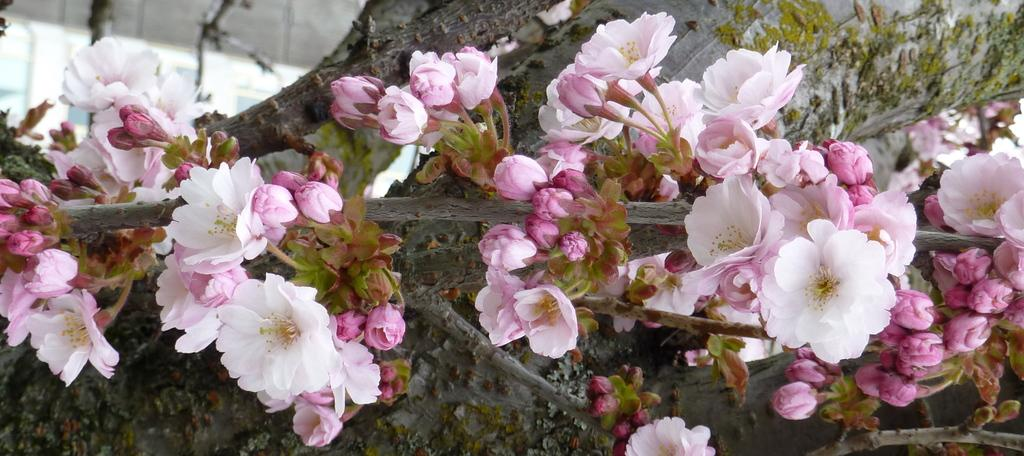What type of plants can be seen in the image? There are flowers in the image. Can you describe the stage of growth for some of the plants in the image? Yes, there are buds in the image, which are flowers in the early stages of development. What type of afterthought can be seen in the image? There is no afterthought present in the image. Can you tell me how many bombs are visible in the image? There are no bombs present in the image. 